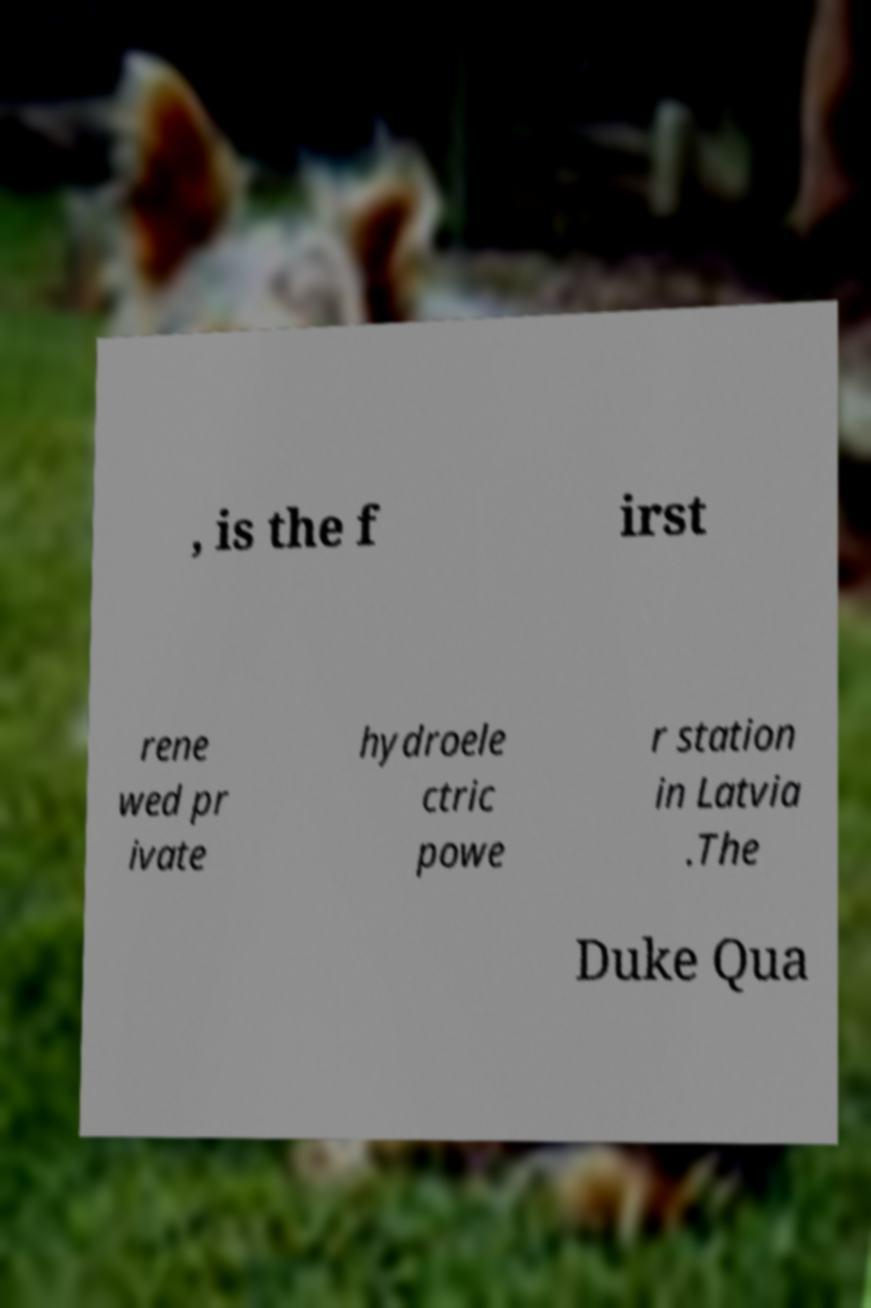I need the written content from this picture converted into text. Can you do that? , is the f irst rene wed pr ivate hydroele ctric powe r station in Latvia .The Duke Qua 